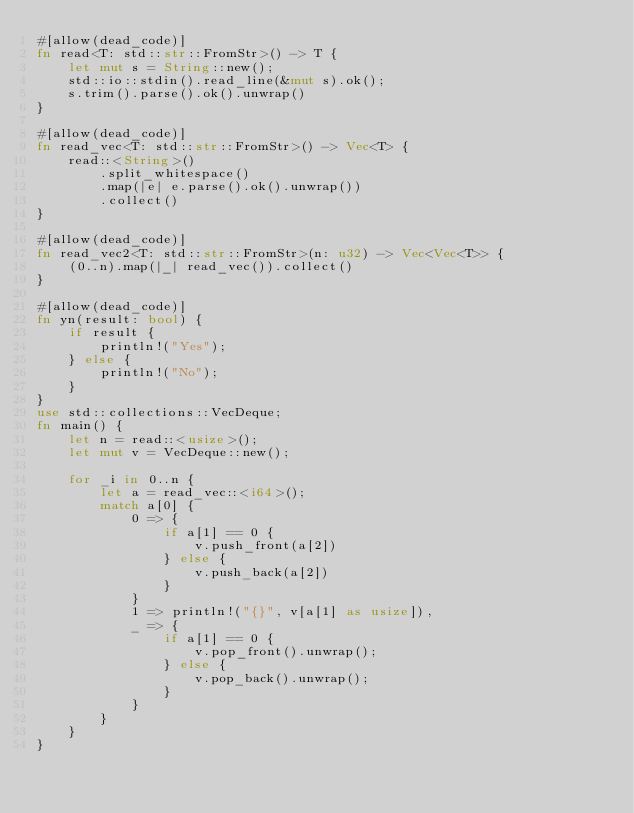<code> <loc_0><loc_0><loc_500><loc_500><_Rust_>#[allow(dead_code)]
fn read<T: std::str::FromStr>() -> T {
    let mut s = String::new();
    std::io::stdin().read_line(&mut s).ok();
    s.trim().parse().ok().unwrap()
}

#[allow(dead_code)]
fn read_vec<T: std::str::FromStr>() -> Vec<T> {
    read::<String>()
        .split_whitespace()
        .map(|e| e.parse().ok().unwrap())
        .collect()
}

#[allow(dead_code)]
fn read_vec2<T: std::str::FromStr>(n: u32) -> Vec<Vec<T>> {
    (0..n).map(|_| read_vec()).collect()
}

#[allow(dead_code)]
fn yn(result: bool) {
    if result {
        println!("Yes");
    } else {
        println!("No");
    }
}
use std::collections::VecDeque;
fn main() {
    let n = read::<usize>();
    let mut v = VecDeque::new();

    for _i in 0..n {
        let a = read_vec::<i64>();
        match a[0] {
            0 => {
                if a[1] == 0 {
                    v.push_front(a[2])
                } else {
                    v.push_back(a[2])
                }
            }
            1 => println!("{}", v[a[1] as usize]),
            _ => {
                if a[1] == 0 {
                    v.pop_front().unwrap();
                } else {
                    v.pop_back().unwrap();
                }
            }
        }
    }
}

</code> 